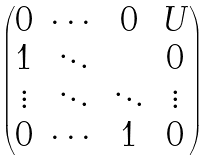Convert formula to latex. <formula><loc_0><loc_0><loc_500><loc_500>\begin{pmatrix} 0 & \cdots & 0 & U \\ 1 & \ddots & & 0 \\ \vdots & \ddots & \ddots & \vdots \\ 0 & \cdots & 1 & 0 \end{pmatrix}</formula> 